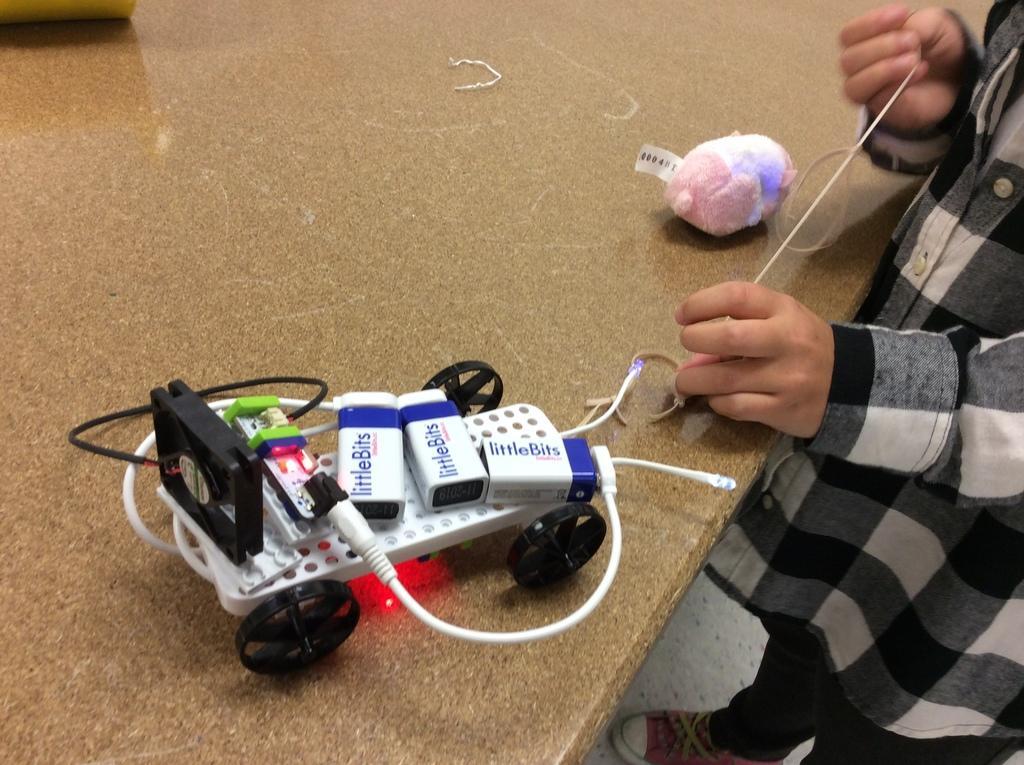Describe this image in one or two sentences. In this image there is a person standing towards the right of the image, the person is holding an object, there is a table towards the left of the image, there are toys on the table, there is an object towards the top of the image. 